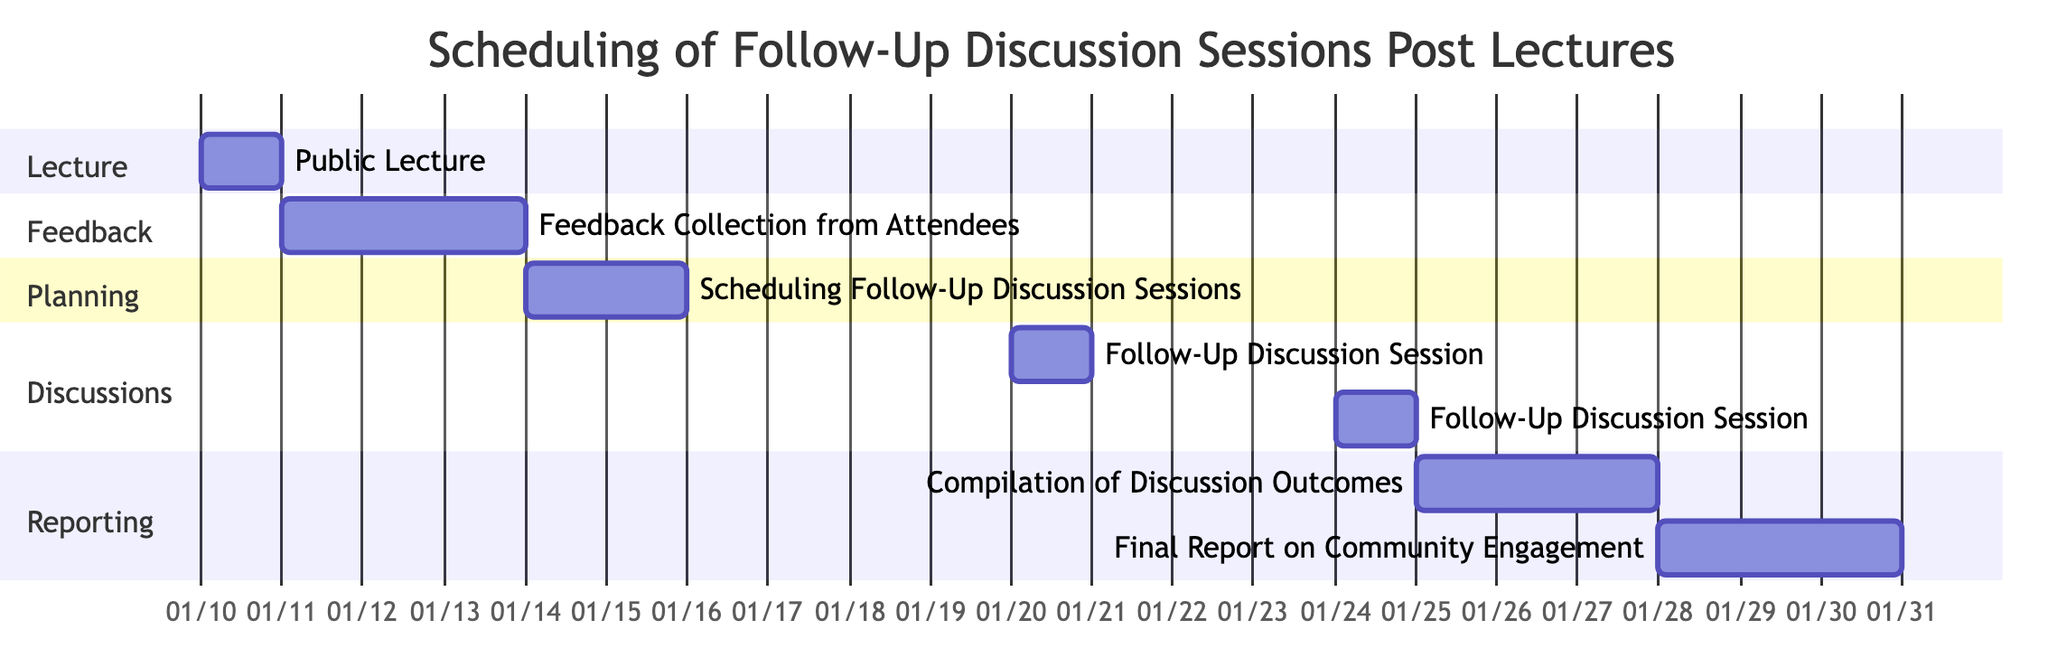What is the duration of the "Feedback Collection from Attendees" task? The duration of the task is indicated directly in the diagram. Here, it shows that it spans for 3 days from January 11 to January 13, 2024.
Answer: 3 days Which task follows the "Scheduling Follow-Up Discussion Sessions"? In the Gantt Chart, the flow of tasks is sequential. After "Scheduling Follow-Up Discussion Sessions," which starts on January 14 and ends on January 15, the next task is "Follow-Up Discussion Session: Community Feedback" starting on January 20.
Answer: Follow-Up Discussion Session: Community Feedback How many days are there between the "Follow-Up Discussion Session: Community Feedback" and the "Follow-Up Discussion Session: Future Topics"? The "Follow-Up Discussion Session: Community Feedback" is scheduled for January 20 and the "Follow-Up Discussion Session: Future Topics" is on January 24. Counting the days, there are 3 days in between (January 21, 22, and 23).
Answer: 3 days What is the total duration of the "Reporting" section? To determine the total duration, we need to assess the individual durations of the tasks in the "Reporting" section. "Compilation of Discussion Outcomes" is 3 days, and "Final Report on Community Engagement" is also 3 days, totaling 6 days for the entire section.
Answer: 6 days What is the start date of the "Final Report on Community Engagement"? The start date of the "Final Report on Community Engagement" is provided in the diagram, which shows it begins on January 28, 2024.
Answer: January 28, 2024 Which task has the earliest start date in the Gantt Chart? By inspecting the tasks from the beginning, the "Public Lecture: Introduction to Community Engagement" starts on January 10, 2024, which is the earliest date among all tasks.
Answer: Public Lecture: Introduction to Community Engagement What are the critical tasks in the "Discussions" section? The critical tasks are highlighted within the section labeled "Discussions." Here, both "Follow-Up Discussion Session: Community Feedback" and "Follow-Up Discussion Session: Future Topics" are marked as critical tasks.
Answer: Follow-Up Discussion Session: Community Feedback, Follow-Up Discussion Session: Future Topics How many total tasks are presented in the diagram? The total number of tasks can be counted directly from the diagram. There are 7 distinct tasks listed, each representing an activity within the scheduling process.
Answer: 7 tasks 